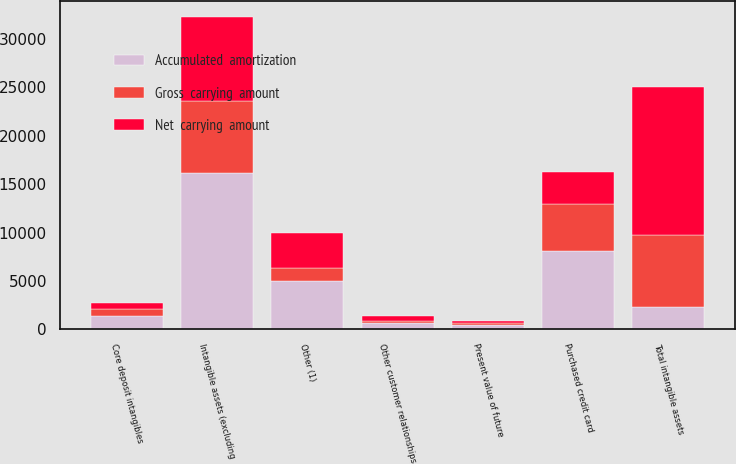Convert chart. <chart><loc_0><loc_0><loc_500><loc_500><stacked_bar_chart><ecel><fcel>Purchased credit card<fcel>Core deposit intangibles<fcel>Other customer relationships<fcel>Present value of future<fcel>Other (1)<fcel>Intangible assets (excluding<fcel>Total intangible assets<nl><fcel>Accumulated  amortization<fcel>8148<fcel>1373<fcel>675<fcel>418<fcel>4977<fcel>16160<fcel>2341.5<nl><fcel>Gross  carrying  amount<fcel>4838<fcel>791<fcel>176<fcel>280<fcel>1361<fcel>7446<fcel>7446<nl><fcel>Net  carrying  amount<fcel>3310<fcel>582<fcel>499<fcel>138<fcel>3616<fcel>8714<fcel>15244<nl></chart> 